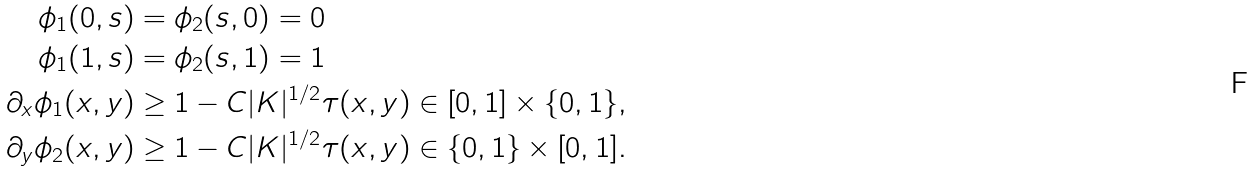<formula> <loc_0><loc_0><loc_500><loc_500>\phi _ { 1 } ( 0 , s ) & = \phi _ { 2 } ( s , 0 ) = 0 \quad \\ \phi _ { 1 } ( 1 , s ) & = \phi _ { 2 } ( s , 1 ) = 1 \quad \\ \partial _ { x } \phi _ { 1 } ( x , y ) & \geq 1 - C | K | ^ { 1 / 2 } \tau ( x , y ) \in [ 0 , 1 ] \times \{ 0 , 1 \} , \\ \partial _ { y } \phi _ { 2 } ( x , y ) & \geq 1 - C | K | ^ { 1 / 2 } \tau ( x , y ) \in \{ 0 , 1 \} \times [ 0 , 1 ] .</formula> 